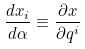Convert formula to latex. <formula><loc_0><loc_0><loc_500><loc_500>\frac { d x _ { i } } { d \alpha } \equiv \frac { \partial x } { \partial q ^ { i } }</formula> 